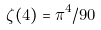Convert formula to latex. <formula><loc_0><loc_0><loc_500><loc_500>\zeta ( 4 ) = \pi ^ { 4 } / 9 0</formula> 